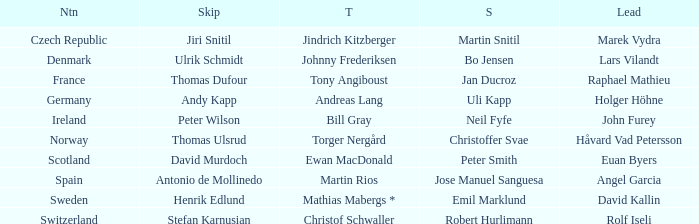Which Lead has a Nation of switzerland? Rolf Iseli. 